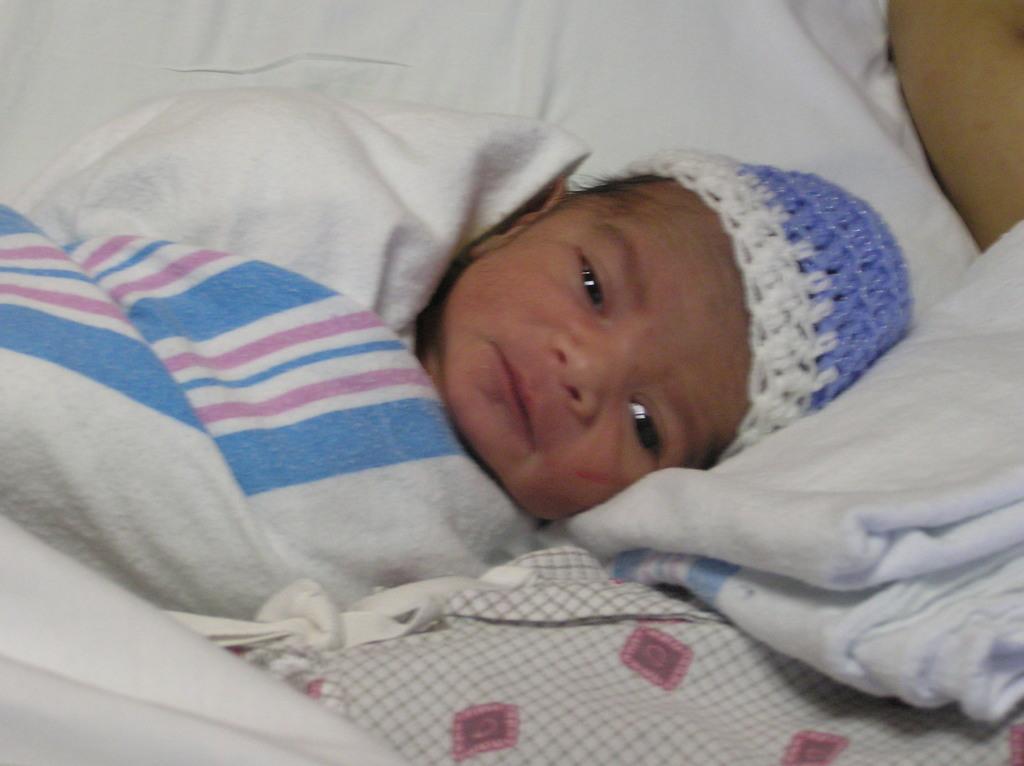In one or two sentences, can you explain what this image depicts? In this picture we can see a baby wore a cap and lying on a white cloth, person hand and some clothes. 